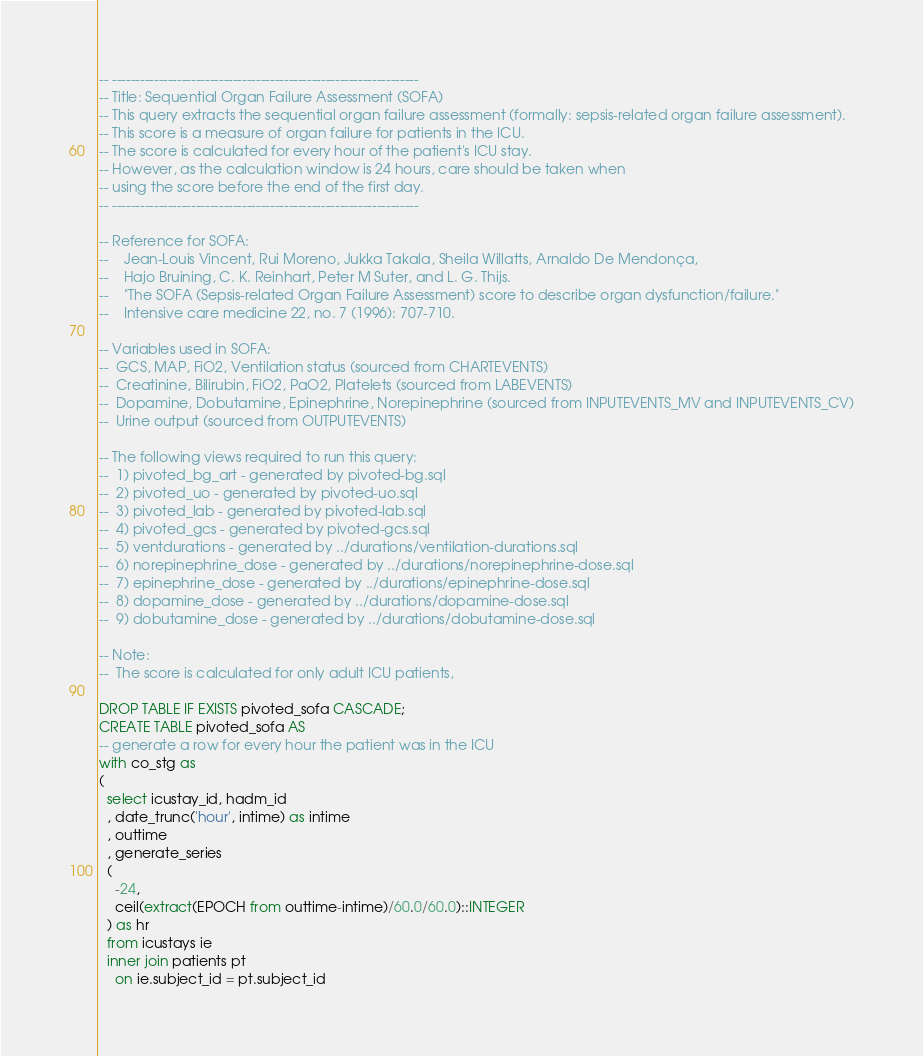<code> <loc_0><loc_0><loc_500><loc_500><_SQL_>-- ------------------------------------------------------------------
-- Title: Sequential Organ Failure Assessment (SOFA)
-- This query extracts the sequential organ failure assessment (formally: sepsis-related organ failure assessment).
-- This score is a measure of organ failure for patients in the ICU.
-- The score is calculated for every hour of the patient's ICU stay.
-- However, as the calculation window is 24 hours, care should be taken when
-- using the score before the end of the first day.
-- ------------------------------------------------------------------

-- Reference for SOFA:
--    Jean-Louis Vincent, Rui Moreno, Jukka Takala, Sheila Willatts, Arnaldo De Mendonça,
--    Hajo Bruining, C. K. Reinhart, Peter M Suter, and L. G. Thijs.
--    "The SOFA (Sepsis-related Organ Failure Assessment) score to describe organ dysfunction/failure."
--    Intensive care medicine 22, no. 7 (1996): 707-710.

-- Variables used in SOFA:
--  GCS, MAP, FiO2, Ventilation status (sourced from CHARTEVENTS)
--  Creatinine, Bilirubin, FiO2, PaO2, Platelets (sourced from LABEVENTS)
--  Dopamine, Dobutamine, Epinephrine, Norepinephrine (sourced from INPUTEVENTS_MV and INPUTEVENTS_CV)
--  Urine output (sourced from OUTPUTEVENTS)

-- The following views required to run this query:
--  1) pivoted_bg_art - generated by pivoted-bg.sql
--  2) pivoted_uo - generated by pivoted-uo.sql
--  3) pivoted_lab - generated by pivoted-lab.sql
--  4) pivoted_gcs - generated by pivoted-gcs.sql
--  5) ventdurations - generated by ../durations/ventilation-durations.sql
--  6) norepinephrine_dose - generated by ../durations/norepinephrine-dose.sql
--  7) epinephrine_dose - generated by ../durations/epinephrine-dose.sql
--  8) dopamine_dose - generated by ../durations/dopamine-dose.sql
--  9) dobutamine_dose - generated by ../durations/dobutamine-dose.sql

-- Note:
--  The score is calculated for only adult ICU patients,

DROP TABLE IF EXISTS pivoted_sofa CASCADE;
CREATE TABLE pivoted_sofa AS
-- generate a row for every hour the patient was in the ICU
with co_stg as
(
  select icustay_id, hadm_id
  , date_trunc('hour', intime) as intime
  , outtime
  , generate_series
  (
    -24,
    ceil(extract(EPOCH from outtime-intime)/60.0/60.0)::INTEGER
  ) as hr
  from icustays ie
  inner join patients pt
    on ie.subject_id = pt.subject_id</code> 